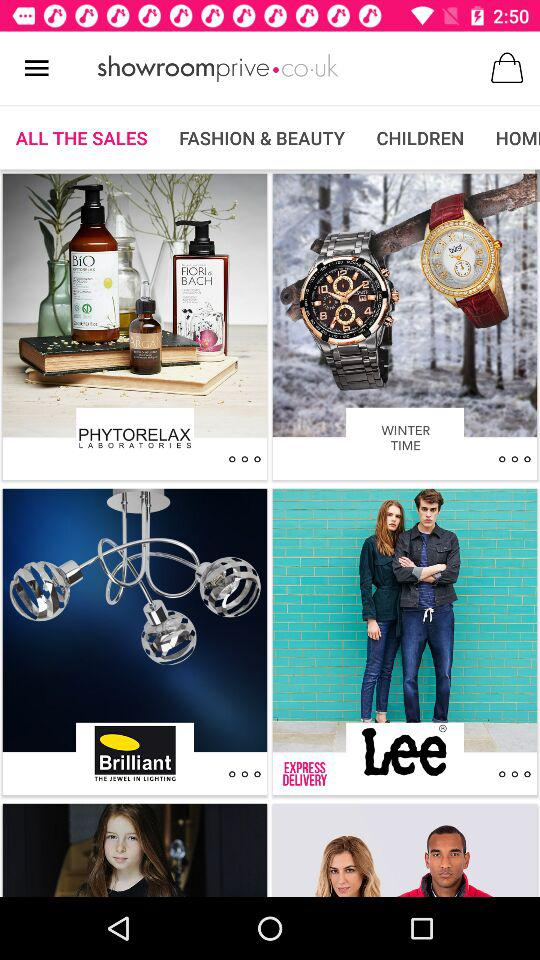Which tab am I on? You are on the "All The Sales" tab. 